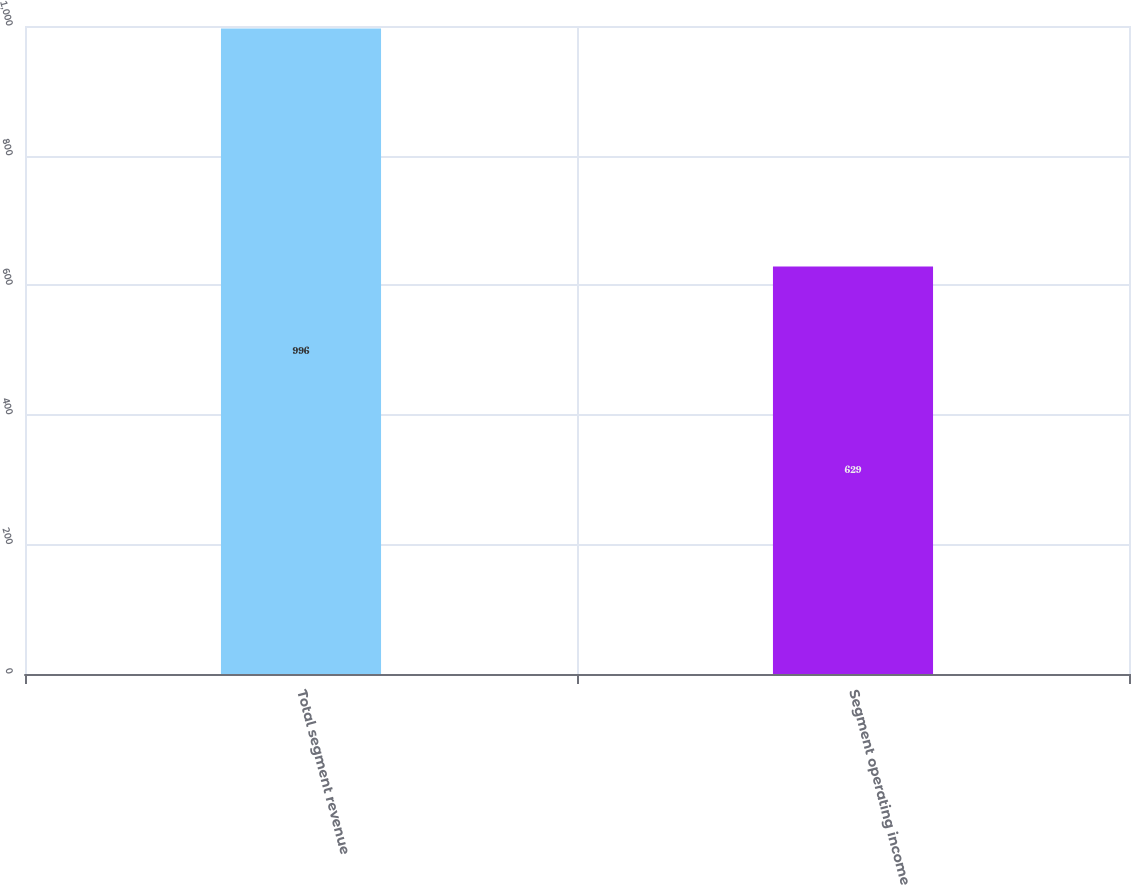Convert chart. <chart><loc_0><loc_0><loc_500><loc_500><bar_chart><fcel>Total segment revenue<fcel>Segment operating income<nl><fcel>996<fcel>629<nl></chart> 